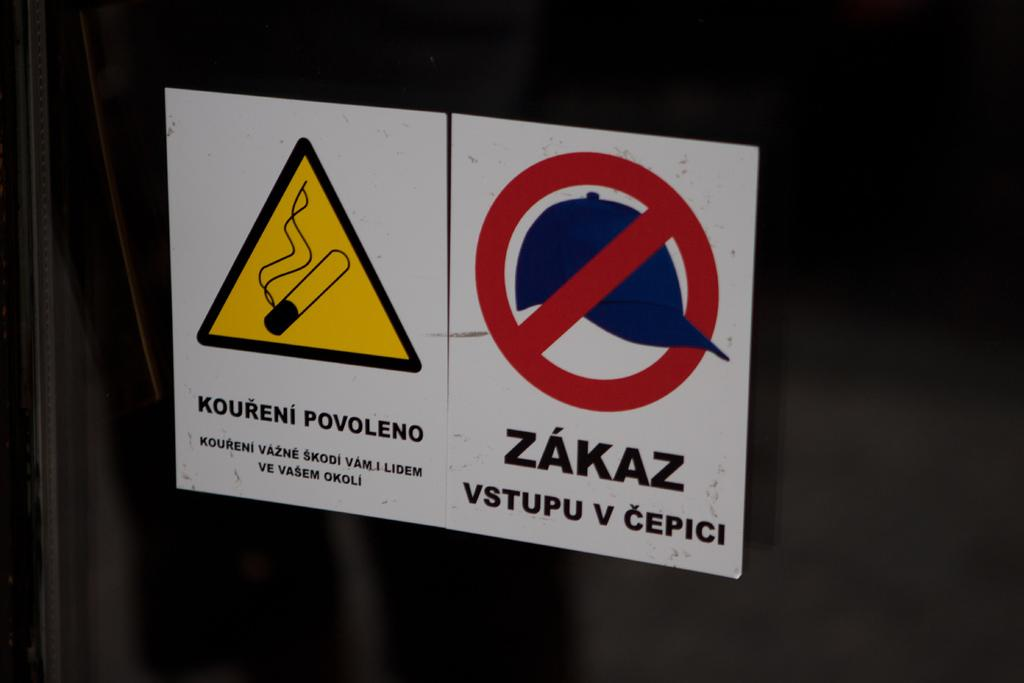Provide a one-sentence caption for the provided image. two different warning signs sitting side by side written in russian. 